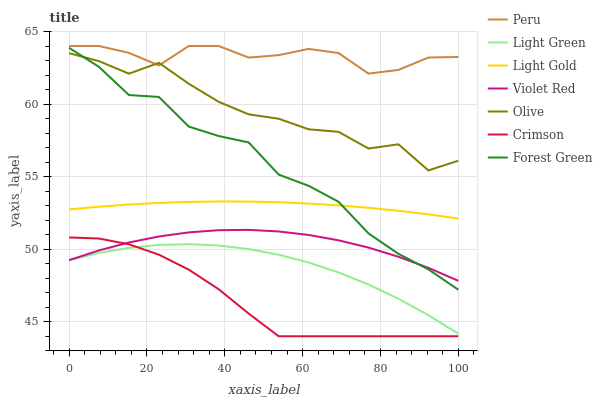Does Crimson have the minimum area under the curve?
Answer yes or no. Yes. Does Peru have the maximum area under the curve?
Answer yes or no. Yes. Does Peru have the minimum area under the curve?
Answer yes or no. No. Does Crimson have the maximum area under the curve?
Answer yes or no. No. Is Light Gold the smoothest?
Answer yes or no. Yes. Is Olive the roughest?
Answer yes or no. Yes. Is Peru the smoothest?
Answer yes or no. No. Is Peru the roughest?
Answer yes or no. No. Does Crimson have the lowest value?
Answer yes or no. Yes. Does Peru have the lowest value?
Answer yes or no. No. Does Peru have the highest value?
Answer yes or no. Yes. Does Crimson have the highest value?
Answer yes or no. No. Is Crimson less than Peru?
Answer yes or no. Yes. Is Olive greater than Light Green?
Answer yes or no. Yes. Does Olive intersect Peru?
Answer yes or no. Yes. Is Olive less than Peru?
Answer yes or no. No. Is Olive greater than Peru?
Answer yes or no. No. Does Crimson intersect Peru?
Answer yes or no. No. 